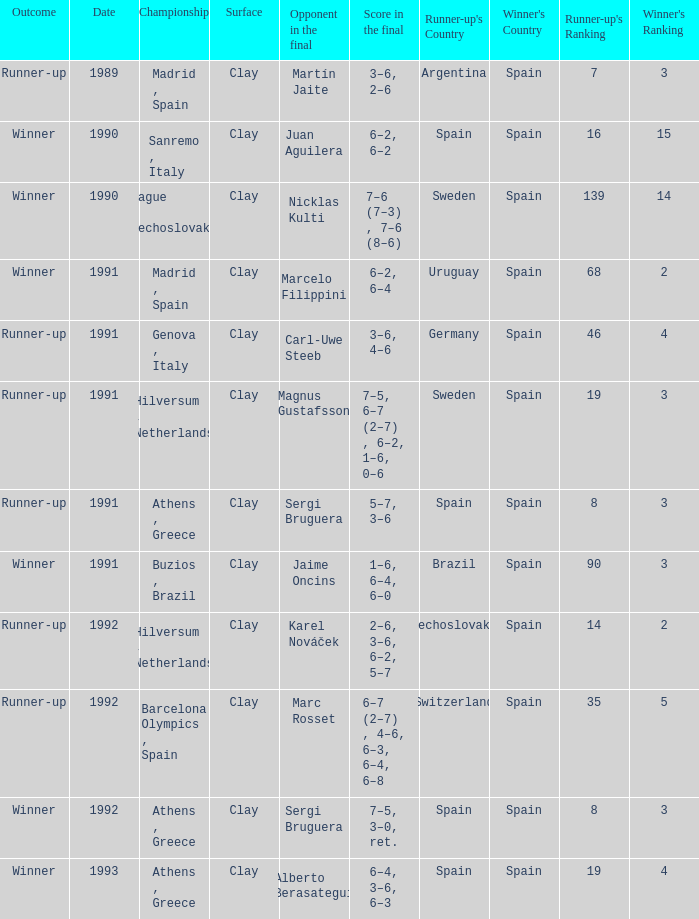What is Score In The Final, when Championship is "Athens , Greece", and when Outcome is "Winner"? 7–5, 3–0, ret., 6–4, 3–6, 6–3. 